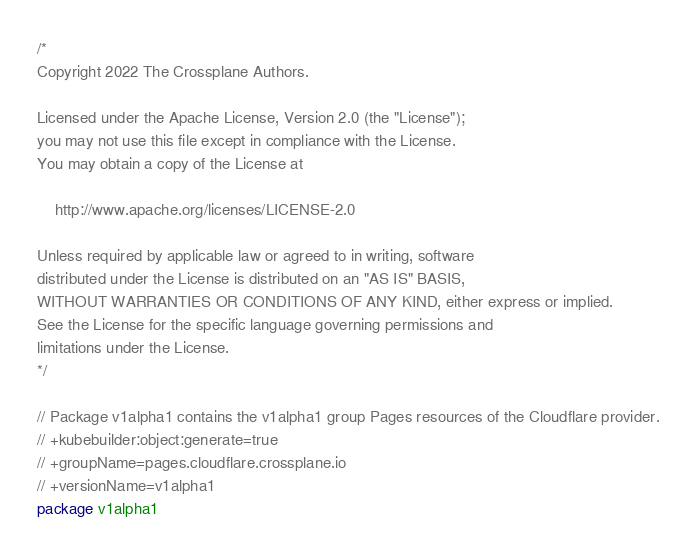<code> <loc_0><loc_0><loc_500><loc_500><_Go_>/*
Copyright 2022 The Crossplane Authors.

Licensed under the Apache License, Version 2.0 (the "License");
you may not use this file except in compliance with the License.
You may obtain a copy of the License at

    http://www.apache.org/licenses/LICENSE-2.0

Unless required by applicable law or agreed to in writing, software
distributed under the License is distributed on an "AS IS" BASIS,
WITHOUT WARRANTIES OR CONDITIONS OF ANY KIND, either express or implied.
See the License for the specific language governing permissions and
limitations under the License.
*/

// Package v1alpha1 contains the v1alpha1 group Pages resources of the Cloudflare provider.
// +kubebuilder:object:generate=true
// +groupName=pages.cloudflare.crossplane.io
// +versionName=v1alpha1
package v1alpha1
</code> 